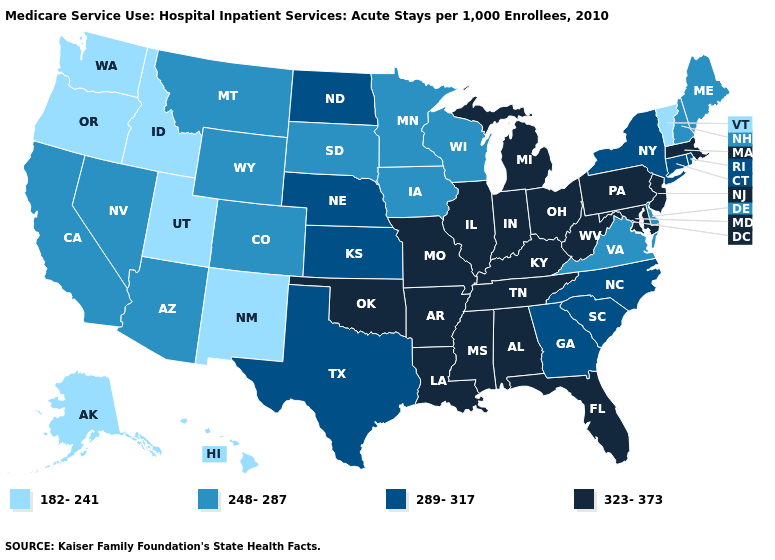Which states have the lowest value in the USA?
Write a very short answer. Alaska, Hawaii, Idaho, New Mexico, Oregon, Utah, Vermont, Washington. Does Massachusetts have the same value as Pennsylvania?
Write a very short answer. Yes. What is the value of Wisconsin?
Answer briefly. 248-287. Name the states that have a value in the range 323-373?
Give a very brief answer. Alabama, Arkansas, Florida, Illinois, Indiana, Kentucky, Louisiana, Maryland, Massachusetts, Michigan, Mississippi, Missouri, New Jersey, Ohio, Oklahoma, Pennsylvania, Tennessee, West Virginia. Does New Jersey have the highest value in the Northeast?
Keep it brief. Yes. Among the states that border California , which have the lowest value?
Concise answer only. Oregon. Is the legend a continuous bar?
Answer briefly. No. Which states have the lowest value in the USA?
Write a very short answer. Alaska, Hawaii, Idaho, New Mexico, Oregon, Utah, Vermont, Washington. Is the legend a continuous bar?
Concise answer only. No. Is the legend a continuous bar?
Answer briefly. No. How many symbols are there in the legend?
Quick response, please. 4. Name the states that have a value in the range 289-317?
Give a very brief answer. Connecticut, Georgia, Kansas, Nebraska, New York, North Carolina, North Dakota, Rhode Island, South Carolina, Texas. Name the states that have a value in the range 248-287?
Concise answer only. Arizona, California, Colorado, Delaware, Iowa, Maine, Minnesota, Montana, Nevada, New Hampshire, South Dakota, Virginia, Wisconsin, Wyoming. Which states have the lowest value in the West?
Quick response, please. Alaska, Hawaii, Idaho, New Mexico, Oregon, Utah, Washington. 